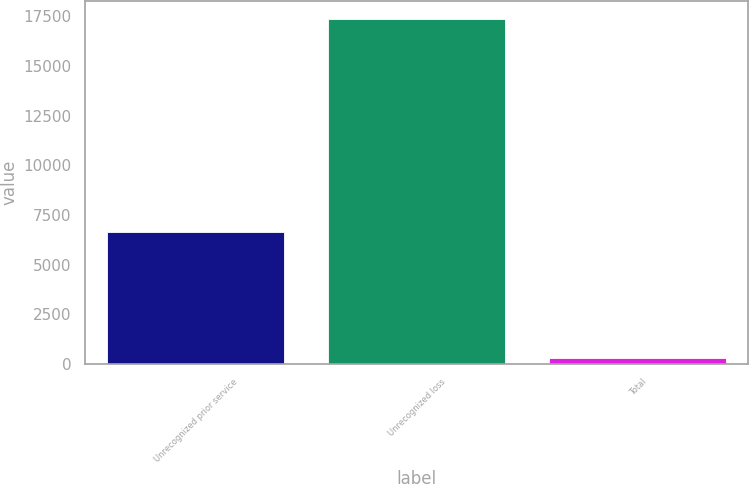Convert chart. <chart><loc_0><loc_0><loc_500><loc_500><bar_chart><fcel>Unrecognized prior service<fcel>Unrecognized loss<fcel>Total<nl><fcel>6672<fcel>17384<fcel>285<nl></chart> 